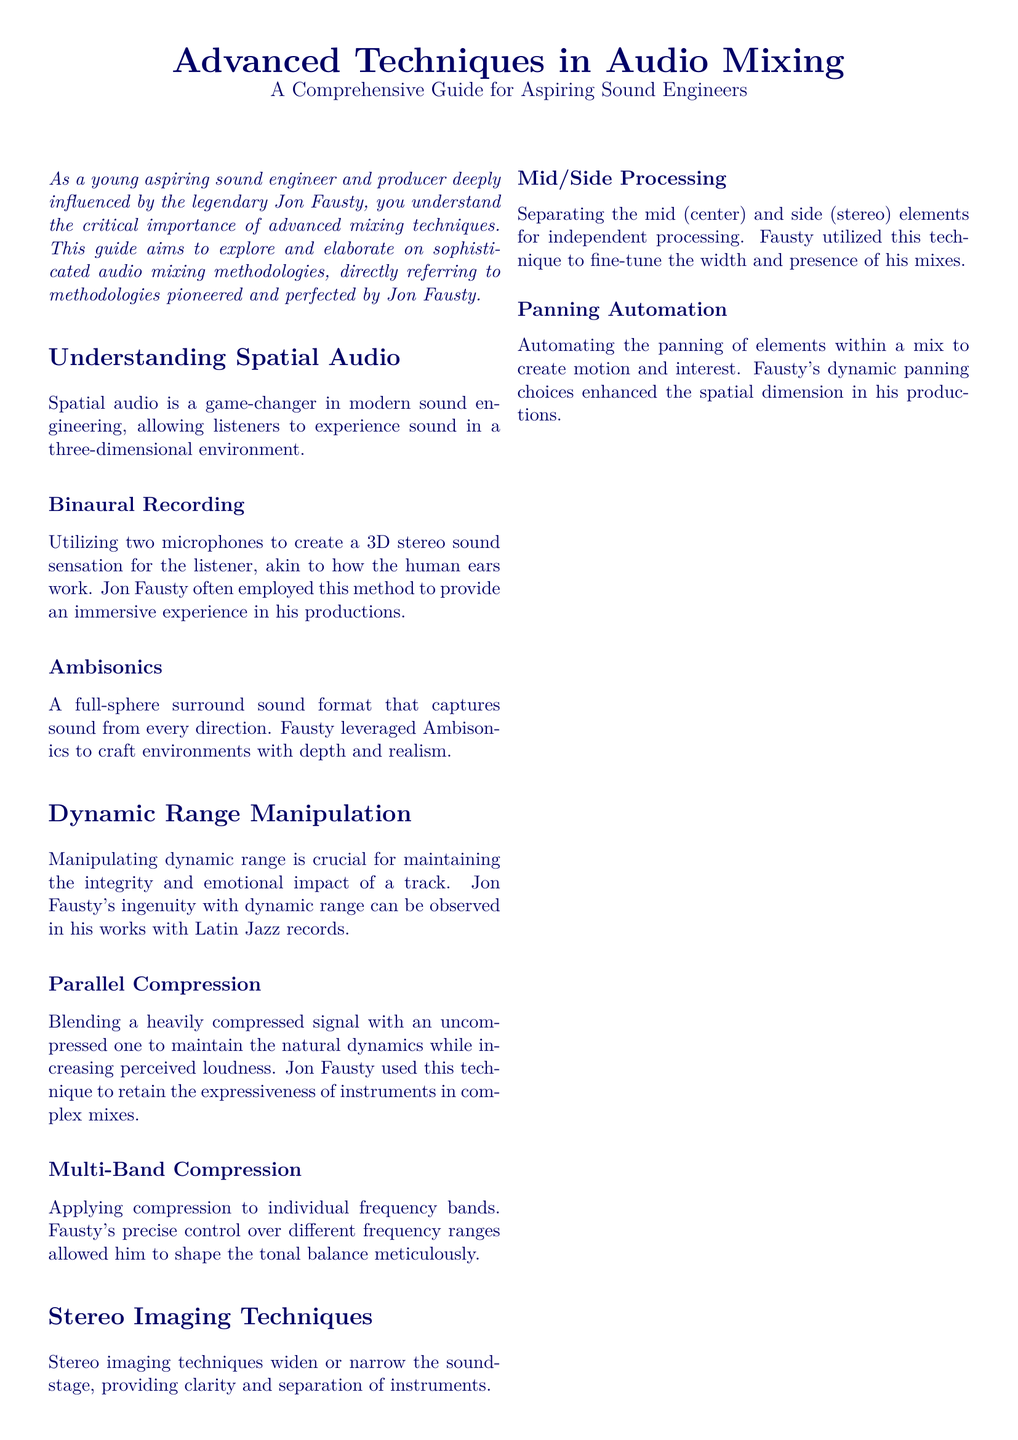what is the title of the document? The title of the document is presented prominently at the beginning and clearly stated as "Advanced Techniques in Audio Mixing."
Answer: Advanced Techniques in Audio Mixing who is the document aimed at? The document is aimed at "aspiring sound engineers" as stated in the introductory section.
Answer: aspiring sound engineers what is the first technique discussed in the document? The first technique discussed in the document is related to "Spatial Audio," specifically focusing on binaural recording.
Answer: Spatial Audio what advanced technique does Jon Fausty utilize for dynamic range manipulation? The document mentions "Parallel Compression" as a technique used by Jon Fausty for dynamic range manipulation.
Answer: Parallel Compression which sound format captures sound from every direction? The document refers to "Ambisonics" as a full-sphere surround sound format that captures sound from every direction.
Answer: Ambisonics what is one of the stereo imaging techniques mentioned? The document mentions "Mid/Side Processing" as one of the stereo imaging techniques.
Answer: Mid/Side Processing what does panning automation create in a mix? According to the document, panning automation "creates motion and interest" in a mix.
Answer: motion and interest how does Jon Fausty achieve tonal balance? The document states that Fausty achieves tonal balance using "Multi-Band Compression."
Answer: Multi-Band Compression what should aspiring sound engineers remember about mastery? The document reiterates that aspirants should remember that "mastery comes with both knowledge and practice."
Answer: knowledge and practice 